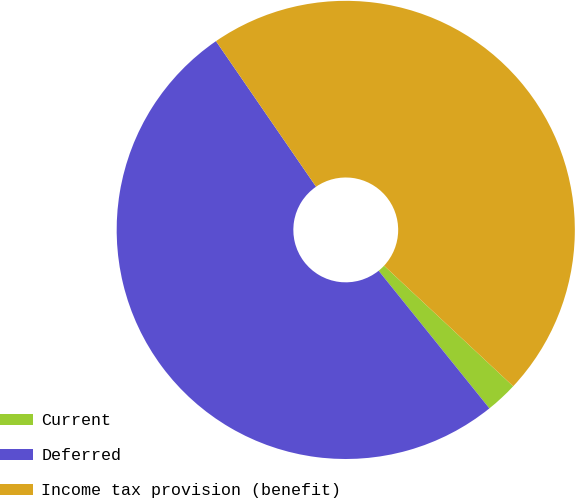Convert chart. <chart><loc_0><loc_0><loc_500><loc_500><pie_chart><fcel>Current<fcel>Deferred<fcel>Income tax provision (benefit)<nl><fcel>2.26%<fcel>51.2%<fcel>46.54%<nl></chart> 